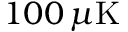Convert formula to latex. <formula><loc_0><loc_0><loc_500><loc_500>1 0 0 \, \mu K</formula> 